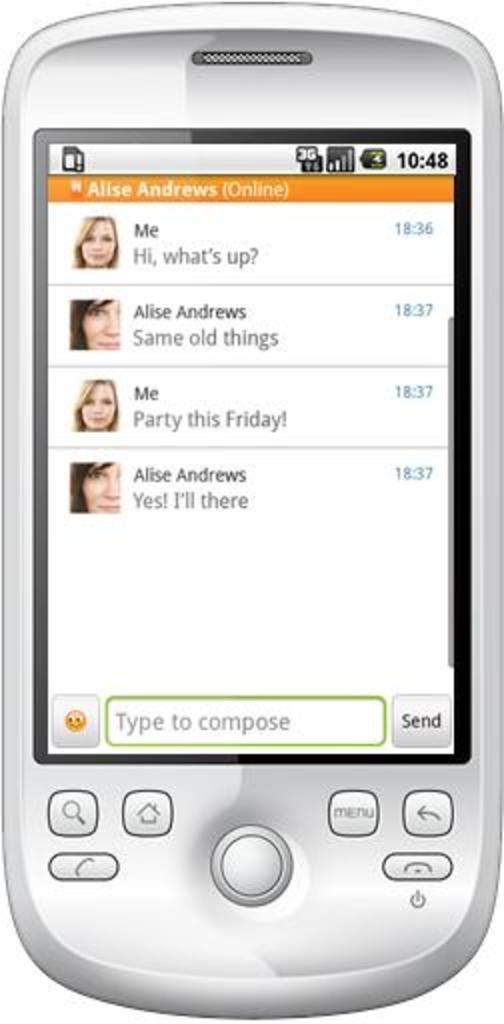Who is texting this phone?
Offer a terse response. Alise andrews. What does the button say on the very bottom right of the screen?
Keep it short and to the point. Send. 